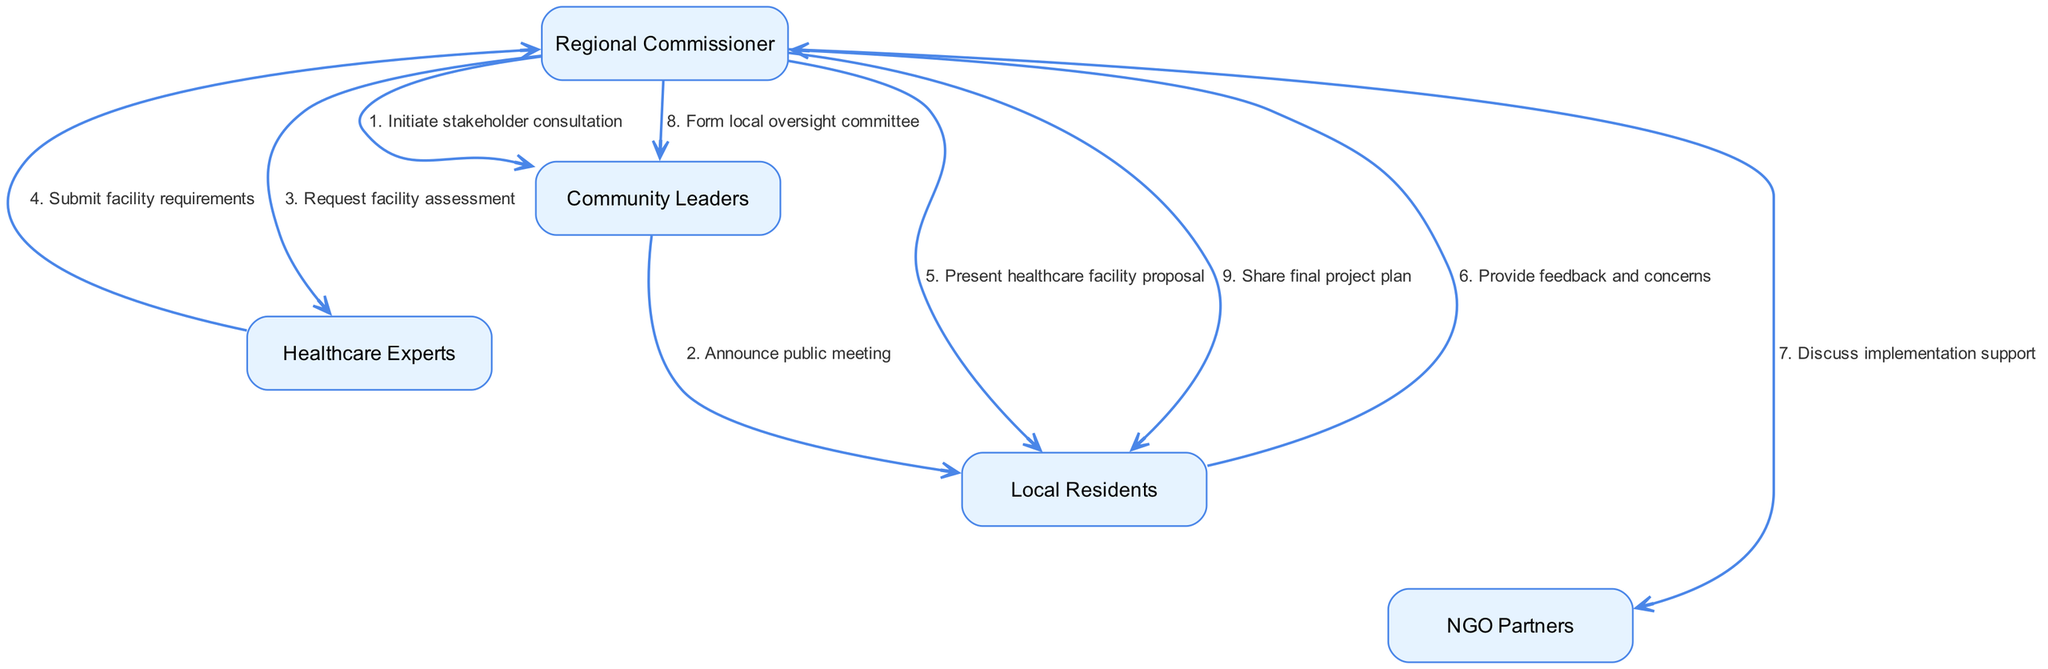What is the first action taken by the Regional Commissioner? The diagram shows that the first action taken by the Regional Commissioner is to initiate stakeholder consultation. This action is directed to the Community Leaders.
Answer: Initiate stakeholder consultation How many actors are involved in the process? Counting the names listed as actors, we find five distinct entities participating in the consultation process: Regional Commissioner, Community Leaders, Healthcare Experts, Local Residents, and NGO Partners.
Answer: 5 Who does the Community Leaders communicate with to announce the public meeting? The Community Leaders are seen announcing the public meeting to the Local Residents, as indicated by the directed edge connecting these two nodes.
Answer: Local Residents What is the last action that the Regional Commissioner performs in the sequence? The final action by the Regional Commissioner is to share the final project plan with the Local Residents, as shown in the last entry of the sequence.
Answer: Share final project plan Which entity is tasked with assessing facility requirements? The diagram illustrates that the Regional Commissioner requests a facility assessment from the Healthcare Experts, thus they are the entity responsible for conducting the assessment.
Answer: Healthcare Experts What feedback do Local Residents provide? In the sequence, it states that Local Residents provide feedback and concerns back to the Regional Commissioner after the healthcare facility proposal is presented.
Answer: Feedback and concerns After what action does the Regional Commissioner form the local oversight committee? The formation of the local oversight committee by the Regional Commissioner occurs after discussing implementation support with NGO Partners, showcasing a need for structured oversight.
Answer: Discuss implementation support Which two actors are directly involved after the healthcare facility proposal is presented? Following the presentation of the healthcare facility proposal, the two actors involved are Local Residents providing feedback and the Regional Commissioner receiving this feedback.
Answer: Regional Commissioner and Local Residents 